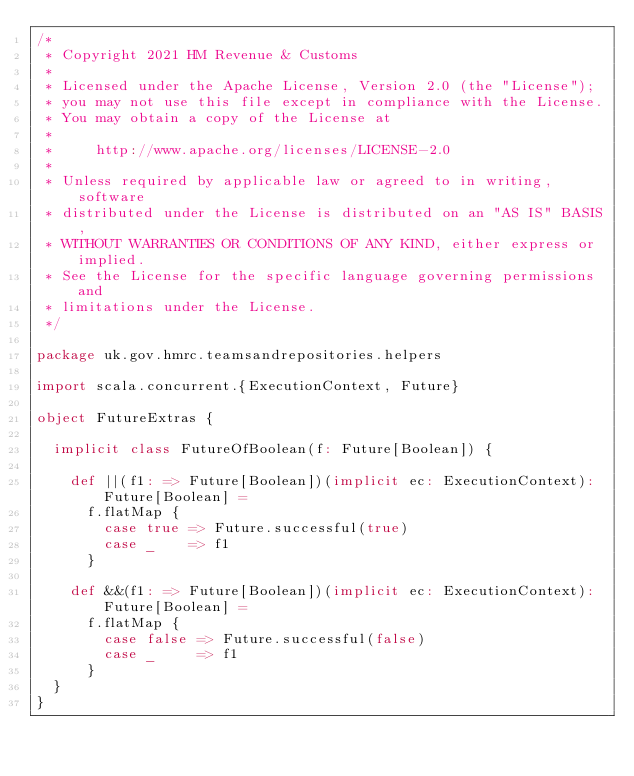Convert code to text. <code><loc_0><loc_0><loc_500><loc_500><_Scala_>/*
 * Copyright 2021 HM Revenue & Customs
 *
 * Licensed under the Apache License, Version 2.0 (the "License");
 * you may not use this file except in compliance with the License.
 * You may obtain a copy of the License at
 *
 *     http://www.apache.org/licenses/LICENSE-2.0
 *
 * Unless required by applicable law or agreed to in writing, software
 * distributed under the License is distributed on an "AS IS" BASIS,
 * WITHOUT WARRANTIES OR CONDITIONS OF ANY KIND, either express or implied.
 * See the License for the specific language governing permissions and
 * limitations under the License.
 */

package uk.gov.hmrc.teamsandrepositories.helpers

import scala.concurrent.{ExecutionContext, Future}

object FutureExtras {

  implicit class FutureOfBoolean(f: Future[Boolean]) {

    def ||(f1: => Future[Boolean])(implicit ec: ExecutionContext): Future[Boolean] =
      f.flatMap {
        case true => Future.successful(true)
        case _    => f1
      }

    def &&(f1: => Future[Boolean])(implicit ec: ExecutionContext): Future[Boolean] =
      f.flatMap {
        case false => Future.successful(false)
        case _     => f1
      }
  }
}
</code> 